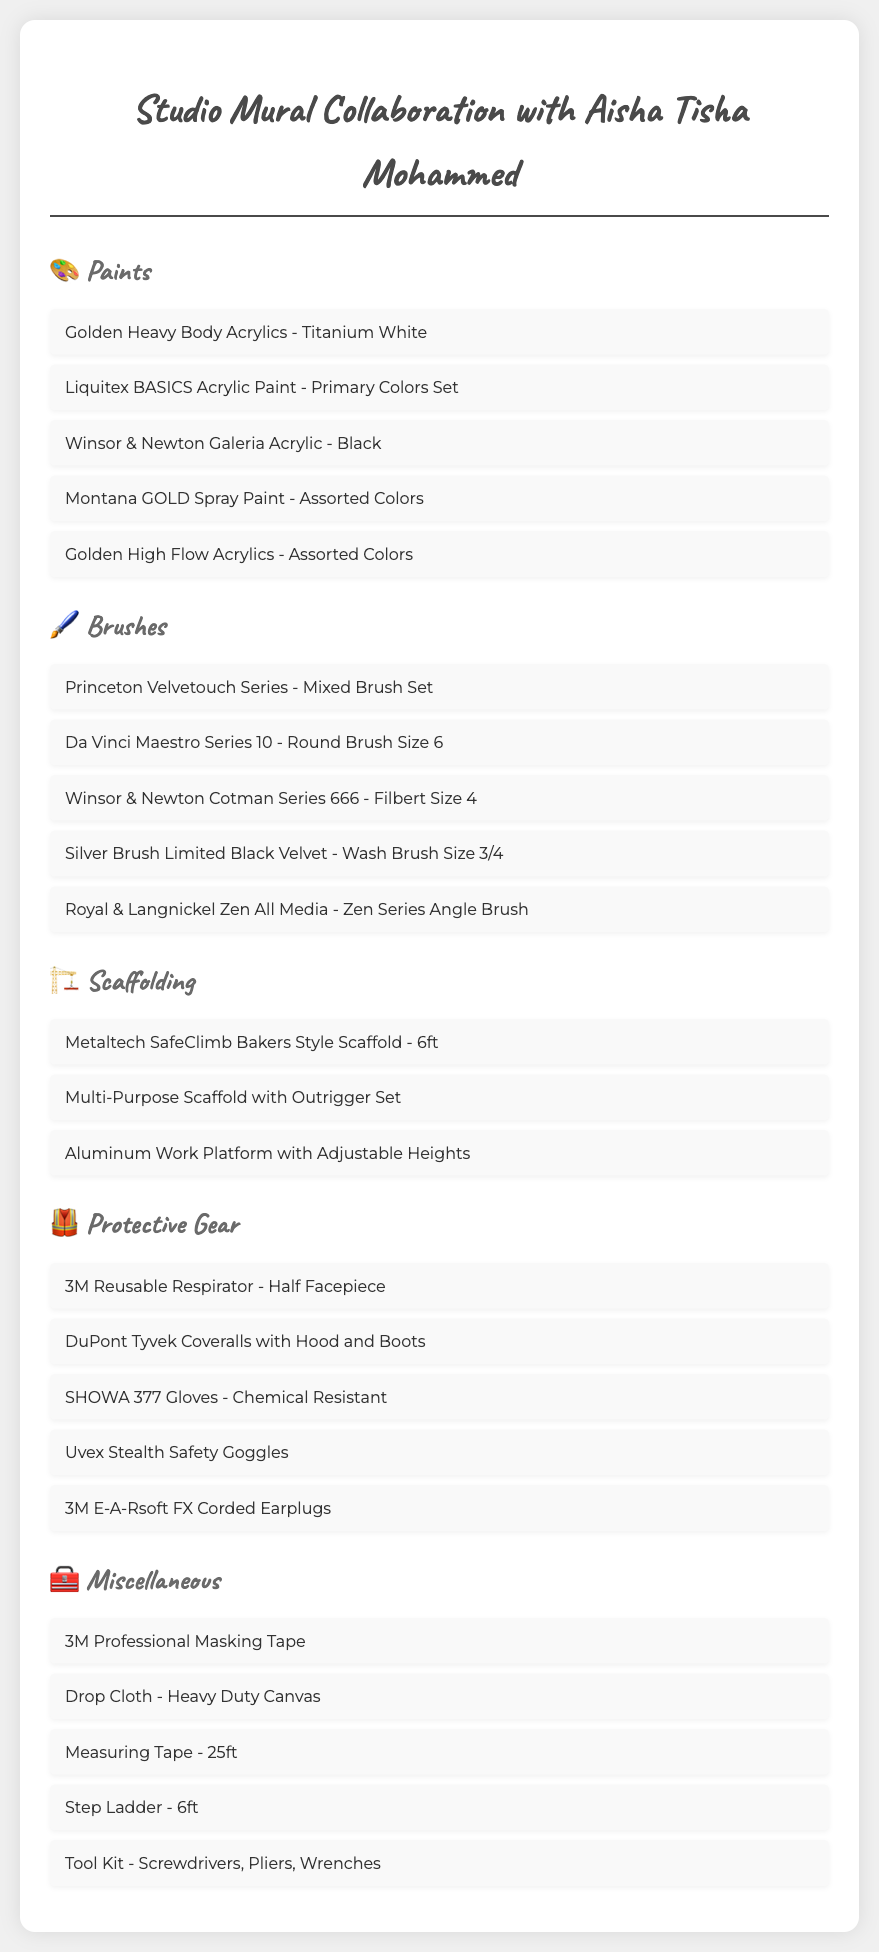What type of paint is listed first? The first paint listed is "Golden Heavy Body Acrylics - Titanium White."
Answer: Golden Heavy Body Acrylics - Titanium White How many types of brushes are included in the list? There are five types of brushes mentioned in the document.
Answer: 5 What scaffolding item has adjustable heights? The item listed that has adjustable heights is "Aluminum Work Platform with Adjustable Heights."
Answer: Aluminum Work Platform with Adjustable Heights What is the purpose of the 3M Reusable Respirator? The 3M Reusable Respirator is for protection while working on the mural.
Answer: Protection Which gear is specified for ear protection? The specified gear for ear protection is "3M E-A-Rsoft FX Corded Earplugs."
Answer: 3M E-A-Rsoft FX Corded Earplugs How many miscellaneous items are listed? There are five miscellaneous items listed in the document.
Answer: 5 